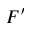<formula> <loc_0><loc_0><loc_500><loc_500>F ^ { \prime }</formula> 